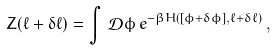<formula> <loc_0><loc_0><loc_500><loc_500>Z ( \ell + \delta \ell ) = \int \, \mathcal { D } \phi \, e ^ { - \beta H ( [ \phi + \delta \phi ] , \ell + \delta \ell ) } \, ,</formula> 